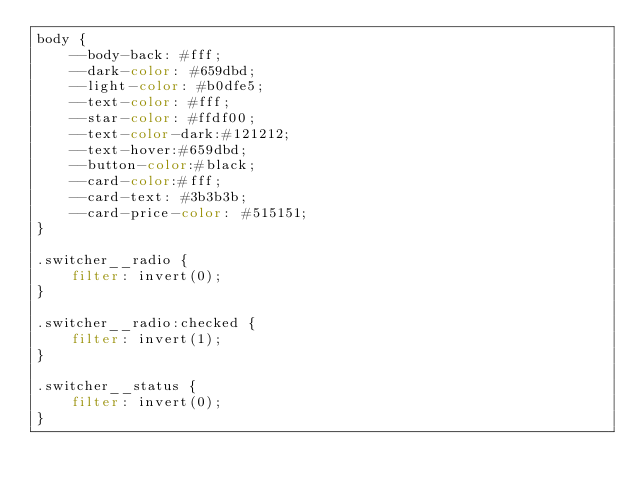Convert code to text. <code><loc_0><loc_0><loc_500><loc_500><_CSS_>body {
    --body-back: #fff;
    --dark-color: #659dbd;
    --light-color: #b0dfe5;
    --text-color: #fff;
    --star-color: #ffdf00;
    --text-color-dark:#121212;
    --text-hover:#659dbd;
    --button-color:#black;
    --card-color:#fff;
    --card-text: #3b3b3b;
    --card-price-color: #515151;
}

.switcher__radio {
    filter: invert(0);
}

.switcher__radio:checked {
    filter: invert(1);
}

.switcher__status {
    filter: invert(0);
}
</code> 